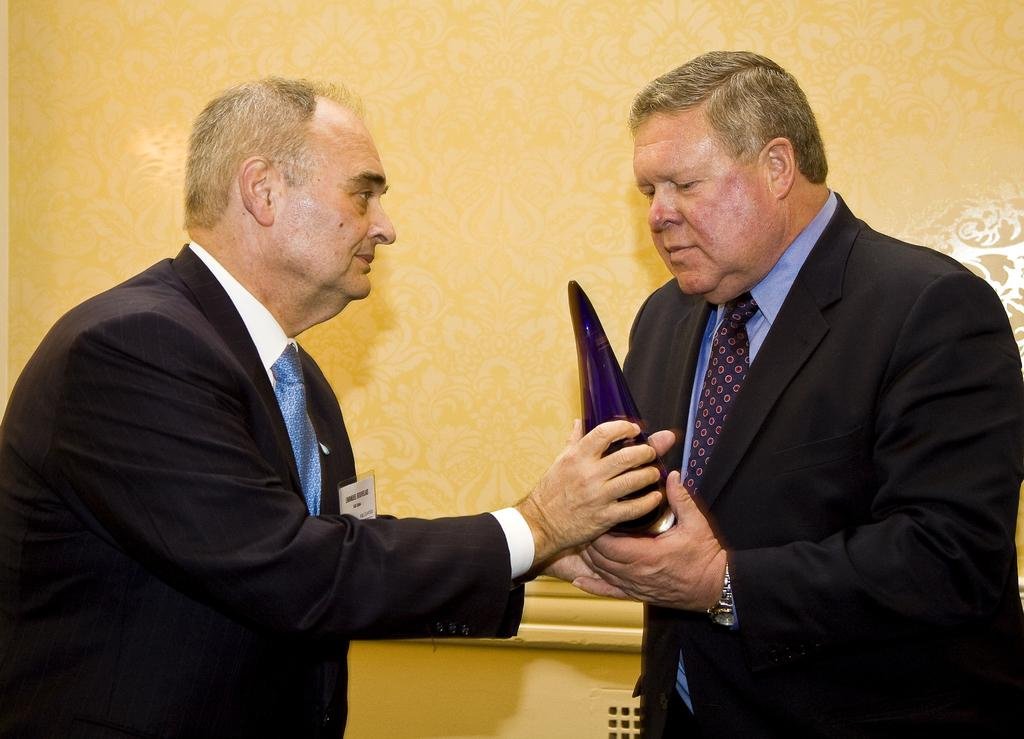What can be seen in the background of the image? There is a wall in the background of the image. Who is present in the image? There are men in the image. What are the men doing in the image? The men are holding an object with their hands. Can you describe any accessories worn by the men? One of the men is wearing a wristwatch. What additional item can be seen in the image? There is a white card visible in the image. What type of pet is visible in the image? There is no pet present in the image. How many suits are being worn by the men in the image? The provided facts do not mention any suits being worn by the men in the image. 